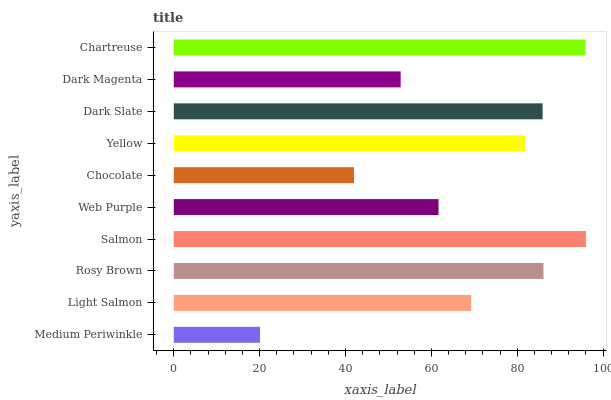Is Medium Periwinkle the minimum?
Answer yes or no. Yes. Is Salmon the maximum?
Answer yes or no. Yes. Is Light Salmon the minimum?
Answer yes or no. No. Is Light Salmon the maximum?
Answer yes or no. No. Is Light Salmon greater than Medium Periwinkle?
Answer yes or no. Yes. Is Medium Periwinkle less than Light Salmon?
Answer yes or no. Yes. Is Medium Periwinkle greater than Light Salmon?
Answer yes or no. No. Is Light Salmon less than Medium Periwinkle?
Answer yes or no. No. Is Yellow the high median?
Answer yes or no. Yes. Is Light Salmon the low median?
Answer yes or no. Yes. Is Web Purple the high median?
Answer yes or no. No. Is Web Purple the low median?
Answer yes or no. No. 